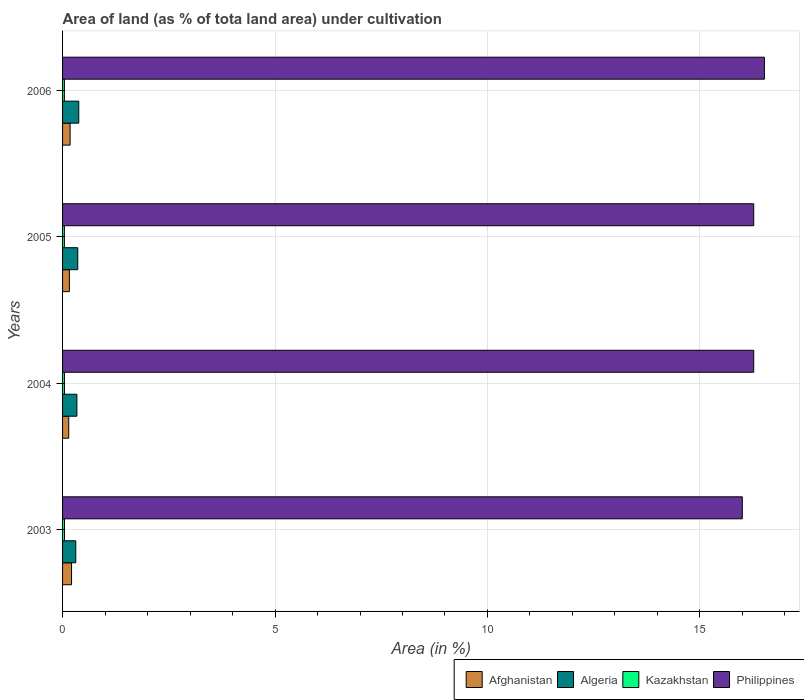How many groups of bars are there?
Your answer should be compact. 4. Are the number of bars per tick equal to the number of legend labels?
Provide a succinct answer. Yes. How many bars are there on the 3rd tick from the top?
Your response must be concise. 4. How many bars are there on the 1st tick from the bottom?
Provide a short and direct response. 4. In how many cases, is the number of bars for a given year not equal to the number of legend labels?
Your answer should be compact. 0. What is the percentage of land under cultivation in Philippines in 2003?
Give a very brief answer. 16. Across all years, what is the maximum percentage of land under cultivation in Kazakhstan?
Provide a short and direct response. 0.05. Across all years, what is the minimum percentage of land under cultivation in Afghanistan?
Give a very brief answer. 0.15. In which year was the percentage of land under cultivation in Afghanistan maximum?
Ensure brevity in your answer.  2003. In which year was the percentage of land under cultivation in Afghanistan minimum?
Keep it short and to the point. 2004. What is the total percentage of land under cultivation in Kazakhstan in the graph?
Your answer should be very brief. 0.18. What is the difference between the percentage of land under cultivation in Algeria in 2003 and that in 2006?
Your answer should be compact. -0.07. What is the difference between the percentage of land under cultivation in Kazakhstan in 2005 and the percentage of land under cultivation in Algeria in 2003?
Ensure brevity in your answer.  -0.27. What is the average percentage of land under cultivation in Kazakhstan per year?
Offer a terse response. 0.04. In the year 2005, what is the difference between the percentage of land under cultivation in Kazakhstan and percentage of land under cultivation in Afghanistan?
Ensure brevity in your answer.  -0.12. In how many years, is the percentage of land under cultivation in Afghanistan greater than 11 %?
Keep it short and to the point. 0. What is the ratio of the percentage of land under cultivation in Kazakhstan in 2004 to that in 2005?
Your answer should be very brief. 1.03. Is the percentage of land under cultivation in Kazakhstan in 2005 less than that in 2006?
Provide a succinct answer. No. Is the difference between the percentage of land under cultivation in Kazakhstan in 2004 and 2006 greater than the difference between the percentage of land under cultivation in Afghanistan in 2004 and 2006?
Offer a very short reply. Yes. What is the difference between the highest and the second highest percentage of land under cultivation in Afghanistan?
Give a very brief answer. 0.03. What is the difference between the highest and the lowest percentage of land under cultivation in Philippines?
Ensure brevity in your answer.  0.52. In how many years, is the percentage of land under cultivation in Philippines greater than the average percentage of land under cultivation in Philippines taken over all years?
Make the answer very short. 3. Is it the case that in every year, the sum of the percentage of land under cultivation in Kazakhstan and percentage of land under cultivation in Afghanistan is greater than the sum of percentage of land under cultivation in Philippines and percentage of land under cultivation in Algeria?
Offer a very short reply. No. What does the 2nd bar from the top in 2005 represents?
Your answer should be very brief. Kazakhstan. What does the 3rd bar from the bottom in 2005 represents?
Your answer should be very brief. Kazakhstan. How many bars are there?
Your answer should be very brief. 16. How many years are there in the graph?
Your answer should be very brief. 4. Are the values on the major ticks of X-axis written in scientific E-notation?
Provide a short and direct response. No. Does the graph contain grids?
Make the answer very short. Yes. How are the legend labels stacked?
Offer a terse response. Horizontal. What is the title of the graph?
Offer a terse response. Area of land (as % of tota land area) under cultivation. What is the label or title of the X-axis?
Ensure brevity in your answer.  Area (in %). What is the label or title of the Y-axis?
Offer a very short reply. Years. What is the Area (in %) of Afghanistan in 2003?
Make the answer very short. 0.21. What is the Area (in %) in Algeria in 2003?
Offer a terse response. 0.31. What is the Area (in %) in Kazakhstan in 2003?
Make the answer very short. 0.05. What is the Area (in %) of Philippines in 2003?
Offer a very short reply. 16. What is the Area (in %) of Afghanistan in 2004?
Offer a very short reply. 0.15. What is the Area (in %) of Algeria in 2004?
Provide a succinct answer. 0.34. What is the Area (in %) in Kazakhstan in 2004?
Provide a short and direct response. 0.04. What is the Area (in %) in Philippines in 2004?
Ensure brevity in your answer.  16.27. What is the Area (in %) of Afghanistan in 2005?
Give a very brief answer. 0.16. What is the Area (in %) in Algeria in 2005?
Give a very brief answer. 0.36. What is the Area (in %) in Kazakhstan in 2005?
Give a very brief answer. 0.04. What is the Area (in %) in Philippines in 2005?
Provide a succinct answer. 16.27. What is the Area (in %) of Afghanistan in 2006?
Keep it short and to the point. 0.18. What is the Area (in %) of Algeria in 2006?
Ensure brevity in your answer.  0.38. What is the Area (in %) of Kazakhstan in 2006?
Provide a succinct answer. 0.04. What is the Area (in %) of Philippines in 2006?
Provide a succinct answer. 16.52. Across all years, what is the maximum Area (in %) of Afghanistan?
Ensure brevity in your answer.  0.21. Across all years, what is the maximum Area (in %) in Algeria?
Offer a terse response. 0.38. Across all years, what is the maximum Area (in %) in Kazakhstan?
Your answer should be very brief. 0.05. Across all years, what is the maximum Area (in %) of Philippines?
Provide a short and direct response. 16.52. Across all years, what is the minimum Area (in %) in Afghanistan?
Provide a short and direct response. 0.15. Across all years, what is the minimum Area (in %) in Algeria?
Your answer should be very brief. 0.31. Across all years, what is the minimum Area (in %) of Kazakhstan?
Give a very brief answer. 0.04. Across all years, what is the minimum Area (in %) in Philippines?
Provide a succinct answer. 16. What is the total Area (in %) in Afghanistan in the graph?
Your response must be concise. 0.7. What is the total Area (in %) of Algeria in the graph?
Provide a short and direct response. 1.39. What is the total Area (in %) in Kazakhstan in the graph?
Keep it short and to the point. 0.18. What is the total Area (in %) of Philippines in the graph?
Offer a terse response. 65.05. What is the difference between the Area (in %) of Afghanistan in 2003 and that in 2004?
Offer a terse response. 0.07. What is the difference between the Area (in %) of Algeria in 2003 and that in 2004?
Offer a very short reply. -0.03. What is the difference between the Area (in %) of Kazakhstan in 2003 and that in 2004?
Offer a very short reply. 0. What is the difference between the Area (in %) of Philippines in 2003 and that in 2004?
Your answer should be compact. -0.27. What is the difference between the Area (in %) in Afghanistan in 2003 and that in 2005?
Ensure brevity in your answer.  0.05. What is the difference between the Area (in %) in Algeria in 2003 and that in 2005?
Offer a very short reply. -0.05. What is the difference between the Area (in %) in Kazakhstan in 2003 and that in 2005?
Your answer should be very brief. 0. What is the difference between the Area (in %) in Philippines in 2003 and that in 2005?
Your answer should be compact. -0.27. What is the difference between the Area (in %) of Afghanistan in 2003 and that in 2006?
Give a very brief answer. 0.03. What is the difference between the Area (in %) in Algeria in 2003 and that in 2006?
Provide a succinct answer. -0.07. What is the difference between the Area (in %) of Kazakhstan in 2003 and that in 2006?
Provide a short and direct response. 0. What is the difference between the Area (in %) in Philippines in 2003 and that in 2006?
Keep it short and to the point. -0.52. What is the difference between the Area (in %) in Afghanistan in 2004 and that in 2005?
Provide a succinct answer. -0.02. What is the difference between the Area (in %) in Algeria in 2004 and that in 2005?
Ensure brevity in your answer.  -0.02. What is the difference between the Area (in %) in Kazakhstan in 2004 and that in 2005?
Offer a very short reply. 0. What is the difference between the Area (in %) in Afghanistan in 2004 and that in 2006?
Your answer should be compact. -0.03. What is the difference between the Area (in %) of Algeria in 2004 and that in 2006?
Offer a very short reply. -0.04. What is the difference between the Area (in %) in Kazakhstan in 2004 and that in 2006?
Keep it short and to the point. 0. What is the difference between the Area (in %) in Philippines in 2004 and that in 2006?
Keep it short and to the point. -0.25. What is the difference between the Area (in %) of Afghanistan in 2005 and that in 2006?
Offer a very short reply. -0.02. What is the difference between the Area (in %) in Algeria in 2005 and that in 2006?
Keep it short and to the point. -0.02. What is the difference between the Area (in %) of Kazakhstan in 2005 and that in 2006?
Give a very brief answer. 0. What is the difference between the Area (in %) of Philippines in 2005 and that in 2006?
Ensure brevity in your answer.  -0.25. What is the difference between the Area (in %) in Afghanistan in 2003 and the Area (in %) in Algeria in 2004?
Keep it short and to the point. -0.13. What is the difference between the Area (in %) of Afghanistan in 2003 and the Area (in %) of Kazakhstan in 2004?
Make the answer very short. 0.17. What is the difference between the Area (in %) of Afghanistan in 2003 and the Area (in %) of Philippines in 2004?
Make the answer very short. -16.05. What is the difference between the Area (in %) in Algeria in 2003 and the Area (in %) in Kazakhstan in 2004?
Provide a short and direct response. 0.27. What is the difference between the Area (in %) in Algeria in 2003 and the Area (in %) in Philippines in 2004?
Provide a short and direct response. -15.95. What is the difference between the Area (in %) of Kazakhstan in 2003 and the Area (in %) of Philippines in 2004?
Your response must be concise. -16.22. What is the difference between the Area (in %) of Afghanistan in 2003 and the Area (in %) of Algeria in 2005?
Provide a short and direct response. -0.15. What is the difference between the Area (in %) of Afghanistan in 2003 and the Area (in %) of Kazakhstan in 2005?
Your answer should be very brief. 0.17. What is the difference between the Area (in %) in Afghanistan in 2003 and the Area (in %) in Philippines in 2005?
Keep it short and to the point. -16.05. What is the difference between the Area (in %) of Algeria in 2003 and the Area (in %) of Kazakhstan in 2005?
Provide a short and direct response. 0.27. What is the difference between the Area (in %) in Algeria in 2003 and the Area (in %) in Philippines in 2005?
Your answer should be very brief. -15.95. What is the difference between the Area (in %) of Kazakhstan in 2003 and the Area (in %) of Philippines in 2005?
Give a very brief answer. -16.22. What is the difference between the Area (in %) in Afghanistan in 2003 and the Area (in %) in Algeria in 2006?
Give a very brief answer. -0.17. What is the difference between the Area (in %) of Afghanistan in 2003 and the Area (in %) of Kazakhstan in 2006?
Keep it short and to the point. 0.17. What is the difference between the Area (in %) in Afghanistan in 2003 and the Area (in %) in Philippines in 2006?
Your response must be concise. -16.31. What is the difference between the Area (in %) in Algeria in 2003 and the Area (in %) in Kazakhstan in 2006?
Keep it short and to the point. 0.27. What is the difference between the Area (in %) of Algeria in 2003 and the Area (in %) of Philippines in 2006?
Keep it short and to the point. -16.21. What is the difference between the Area (in %) in Kazakhstan in 2003 and the Area (in %) in Philippines in 2006?
Ensure brevity in your answer.  -16.47. What is the difference between the Area (in %) of Afghanistan in 2004 and the Area (in %) of Algeria in 2005?
Your response must be concise. -0.21. What is the difference between the Area (in %) in Afghanistan in 2004 and the Area (in %) in Kazakhstan in 2005?
Offer a very short reply. 0.1. What is the difference between the Area (in %) in Afghanistan in 2004 and the Area (in %) in Philippines in 2005?
Give a very brief answer. -16.12. What is the difference between the Area (in %) of Algeria in 2004 and the Area (in %) of Kazakhstan in 2005?
Offer a very short reply. 0.29. What is the difference between the Area (in %) of Algeria in 2004 and the Area (in %) of Philippines in 2005?
Ensure brevity in your answer.  -15.93. What is the difference between the Area (in %) in Kazakhstan in 2004 and the Area (in %) in Philippines in 2005?
Your answer should be very brief. -16.22. What is the difference between the Area (in %) of Afghanistan in 2004 and the Area (in %) of Algeria in 2006?
Ensure brevity in your answer.  -0.24. What is the difference between the Area (in %) of Afghanistan in 2004 and the Area (in %) of Kazakhstan in 2006?
Ensure brevity in your answer.  0.1. What is the difference between the Area (in %) in Afghanistan in 2004 and the Area (in %) in Philippines in 2006?
Keep it short and to the point. -16.37. What is the difference between the Area (in %) of Algeria in 2004 and the Area (in %) of Kazakhstan in 2006?
Your answer should be very brief. 0.29. What is the difference between the Area (in %) of Algeria in 2004 and the Area (in %) of Philippines in 2006?
Ensure brevity in your answer.  -16.18. What is the difference between the Area (in %) in Kazakhstan in 2004 and the Area (in %) in Philippines in 2006?
Offer a very short reply. -16.47. What is the difference between the Area (in %) in Afghanistan in 2005 and the Area (in %) in Algeria in 2006?
Provide a succinct answer. -0.22. What is the difference between the Area (in %) of Afghanistan in 2005 and the Area (in %) of Kazakhstan in 2006?
Your answer should be very brief. 0.12. What is the difference between the Area (in %) in Afghanistan in 2005 and the Area (in %) in Philippines in 2006?
Your answer should be very brief. -16.36. What is the difference between the Area (in %) in Algeria in 2005 and the Area (in %) in Kazakhstan in 2006?
Provide a short and direct response. 0.31. What is the difference between the Area (in %) in Algeria in 2005 and the Area (in %) in Philippines in 2006?
Give a very brief answer. -16.16. What is the difference between the Area (in %) in Kazakhstan in 2005 and the Area (in %) in Philippines in 2006?
Your response must be concise. -16.47. What is the average Area (in %) in Afghanistan per year?
Make the answer very short. 0.17. What is the average Area (in %) of Algeria per year?
Give a very brief answer. 0.35. What is the average Area (in %) of Kazakhstan per year?
Ensure brevity in your answer.  0.04. What is the average Area (in %) in Philippines per year?
Your response must be concise. 16.26. In the year 2003, what is the difference between the Area (in %) of Afghanistan and Area (in %) of Algeria?
Ensure brevity in your answer.  -0.1. In the year 2003, what is the difference between the Area (in %) of Afghanistan and Area (in %) of Kazakhstan?
Make the answer very short. 0.17. In the year 2003, what is the difference between the Area (in %) in Afghanistan and Area (in %) in Philippines?
Your answer should be very brief. -15.79. In the year 2003, what is the difference between the Area (in %) in Algeria and Area (in %) in Kazakhstan?
Ensure brevity in your answer.  0.27. In the year 2003, what is the difference between the Area (in %) of Algeria and Area (in %) of Philippines?
Offer a terse response. -15.69. In the year 2003, what is the difference between the Area (in %) in Kazakhstan and Area (in %) in Philippines?
Provide a succinct answer. -15.95. In the year 2004, what is the difference between the Area (in %) of Afghanistan and Area (in %) of Algeria?
Your answer should be compact. -0.19. In the year 2004, what is the difference between the Area (in %) of Afghanistan and Area (in %) of Kazakhstan?
Provide a succinct answer. 0.1. In the year 2004, what is the difference between the Area (in %) of Afghanistan and Area (in %) of Philippines?
Ensure brevity in your answer.  -16.12. In the year 2004, what is the difference between the Area (in %) of Algeria and Area (in %) of Kazakhstan?
Ensure brevity in your answer.  0.29. In the year 2004, what is the difference between the Area (in %) in Algeria and Area (in %) in Philippines?
Offer a very short reply. -15.93. In the year 2004, what is the difference between the Area (in %) in Kazakhstan and Area (in %) in Philippines?
Give a very brief answer. -16.22. In the year 2005, what is the difference between the Area (in %) of Afghanistan and Area (in %) of Algeria?
Make the answer very short. -0.2. In the year 2005, what is the difference between the Area (in %) in Afghanistan and Area (in %) in Kazakhstan?
Keep it short and to the point. 0.12. In the year 2005, what is the difference between the Area (in %) in Afghanistan and Area (in %) in Philippines?
Provide a succinct answer. -16.11. In the year 2005, what is the difference between the Area (in %) of Algeria and Area (in %) of Kazakhstan?
Give a very brief answer. 0.31. In the year 2005, what is the difference between the Area (in %) of Algeria and Area (in %) of Philippines?
Keep it short and to the point. -15.91. In the year 2005, what is the difference between the Area (in %) in Kazakhstan and Area (in %) in Philippines?
Your answer should be compact. -16.22. In the year 2006, what is the difference between the Area (in %) of Afghanistan and Area (in %) of Algeria?
Make the answer very short. -0.2. In the year 2006, what is the difference between the Area (in %) in Afghanistan and Area (in %) in Kazakhstan?
Your answer should be very brief. 0.13. In the year 2006, what is the difference between the Area (in %) of Afghanistan and Area (in %) of Philippines?
Ensure brevity in your answer.  -16.34. In the year 2006, what is the difference between the Area (in %) in Algeria and Area (in %) in Kazakhstan?
Provide a succinct answer. 0.34. In the year 2006, what is the difference between the Area (in %) of Algeria and Area (in %) of Philippines?
Provide a short and direct response. -16.14. In the year 2006, what is the difference between the Area (in %) of Kazakhstan and Area (in %) of Philippines?
Ensure brevity in your answer.  -16.47. What is the ratio of the Area (in %) of Afghanistan in 2003 to that in 2004?
Keep it short and to the point. 1.45. What is the ratio of the Area (in %) of Algeria in 2003 to that in 2004?
Provide a succinct answer. 0.92. What is the ratio of the Area (in %) of Kazakhstan in 2003 to that in 2004?
Give a very brief answer. 1.02. What is the ratio of the Area (in %) of Philippines in 2003 to that in 2004?
Give a very brief answer. 0.98. What is the ratio of the Area (in %) of Afghanistan in 2003 to that in 2005?
Offer a terse response. 1.31. What is the ratio of the Area (in %) of Algeria in 2003 to that in 2005?
Ensure brevity in your answer.  0.87. What is the ratio of the Area (in %) of Kazakhstan in 2003 to that in 2005?
Make the answer very short. 1.05. What is the ratio of the Area (in %) in Philippines in 2003 to that in 2005?
Give a very brief answer. 0.98. What is the ratio of the Area (in %) of Afghanistan in 2003 to that in 2006?
Ensure brevity in your answer.  1.19. What is the ratio of the Area (in %) in Algeria in 2003 to that in 2006?
Your response must be concise. 0.82. What is the ratio of the Area (in %) in Kazakhstan in 2003 to that in 2006?
Make the answer very short. 1.05. What is the ratio of the Area (in %) of Philippines in 2003 to that in 2006?
Offer a very short reply. 0.97. What is the ratio of the Area (in %) in Afghanistan in 2004 to that in 2005?
Provide a short and direct response. 0.9. What is the ratio of the Area (in %) in Algeria in 2004 to that in 2005?
Provide a short and direct response. 0.94. What is the ratio of the Area (in %) in Kazakhstan in 2004 to that in 2005?
Provide a short and direct response. 1.03. What is the ratio of the Area (in %) of Philippines in 2004 to that in 2005?
Provide a succinct answer. 1. What is the ratio of the Area (in %) of Afghanistan in 2004 to that in 2006?
Make the answer very short. 0.82. What is the ratio of the Area (in %) of Algeria in 2004 to that in 2006?
Offer a terse response. 0.88. What is the ratio of the Area (in %) of Kazakhstan in 2004 to that in 2006?
Provide a succinct answer. 1.04. What is the ratio of the Area (in %) in Philippines in 2004 to that in 2006?
Provide a short and direct response. 0.98. What is the ratio of the Area (in %) in Afghanistan in 2005 to that in 2006?
Ensure brevity in your answer.  0.91. What is the ratio of the Area (in %) of Algeria in 2005 to that in 2006?
Your answer should be very brief. 0.94. What is the ratio of the Area (in %) of Philippines in 2005 to that in 2006?
Offer a terse response. 0.98. What is the difference between the highest and the second highest Area (in %) in Afghanistan?
Provide a short and direct response. 0.03. What is the difference between the highest and the second highest Area (in %) in Algeria?
Your answer should be very brief. 0.02. What is the difference between the highest and the second highest Area (in %) in Kazakhstan?
Give a very brief answer. 0. What is the difference between the highest and the second highest Area (in %) in Philippines?
Provide a short and direct response. 0.25. What is the difference between the highest and the lowest Area (in %) of Afghanistan?
Offer a terse response. 0.07. What is the difference between the highest and the lowest Area (in %) of Algeria?
Your answer should be compact. 0.07. What is the difference between the highest and the lowest Area (in %) of Kazakhstan?
Provide a succinct answer. 0. What is the difference between the highest and the lowest Area (in %) in Philippines?
Provide a succinct answer. 0.52. 